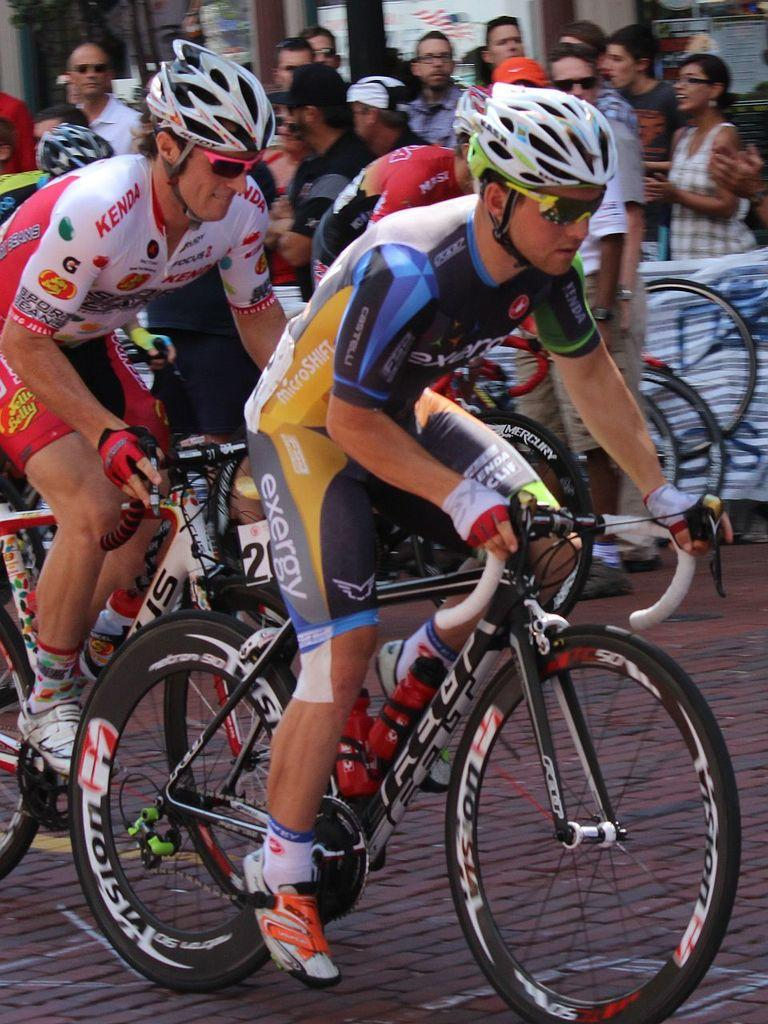How many people are present in the image? There are multiple people in the image. What are some of the people doing in the image? Some of the people are on cycles, while the rest are on a path. What type of soup is being served to the father in the image? There is no father or soup present in the image. 